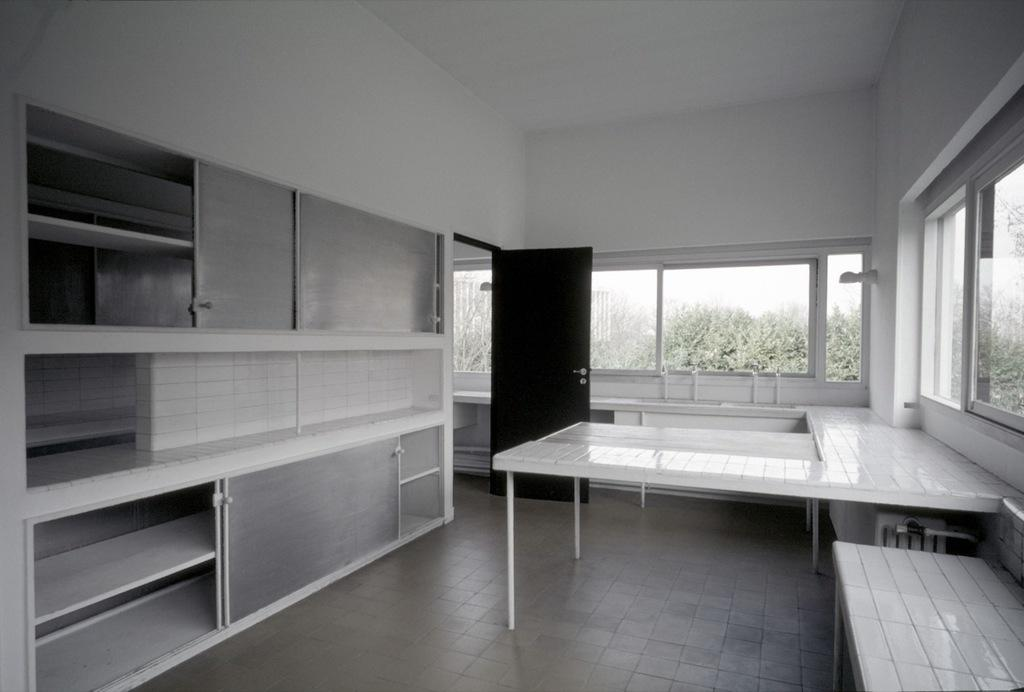What is the primary surface visible in the image? There is a floor in the image. What type of furniture can be seen in the image? There are tables in the image. Where are the cupboards located in the image? The cupboards are on the left side of the image. What architectural feature is present on the wall in the image? There is a wall with glass windows in the image. What type of entrance is visible on the left side of the image? There is a door on the left side of the image. How many clocks can be seen hanging on the wall in the image? There are no clocks visible in the image. What type of downtown area is depicted in the image? The image does not depict a downtown area; it features a room with a floor, tables, cupboards, a wall with glass windows, and a door. 